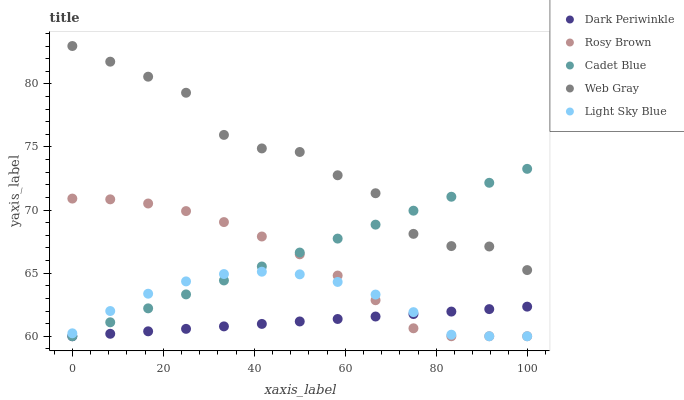Does Dark Periwinkle have the minimum area under the curve?
Answer yes or no. Yes. Does Web Gray have the maximum area under the curve?
Answer yes or no. Yes. Does Rosy Brown have the minimum area under the curve?
Answer yes or no. No. Does Rosy Brown have the maximum area under the curve?
Answer yes or no. No. Is Dark Periwinkle the smoothest?
Answer yes or no. Yes. Is Web Gray the roughest?
Answer yes or no. Yes. Is Rosy Brown the smoothest?
Answer yes or no. No. Is Rosy Brown the roughest?
Answer yes or no. No. Does Cadet Blue have the lowest value?
Answer yes or no. Yes. Does Web Gray have the lowest value?
Answer yes or no. No. Does Web Gray have the highest value?
Answer yes or no. Yes. Does Rosy Brown have the highest value?
Answer yes or no. No. Is Rosy Brown less than Web Gray?
Answer yes or no. Yes. Is Web Gray greater than Rosy Brown?
Answer yes or no. Yes. Does Dark Periwinkle intersect Rosy Brown?
Answer yes or no. Yes. Is Dark Periwinkle less than Rosy Brown?
Answer yes or no. No. Is Dark Periwinkle greater than Rosy Brown?
Answer yes or no. No. Does Rosy Brown intersect Web Gray?
Answer yes or no. No. 